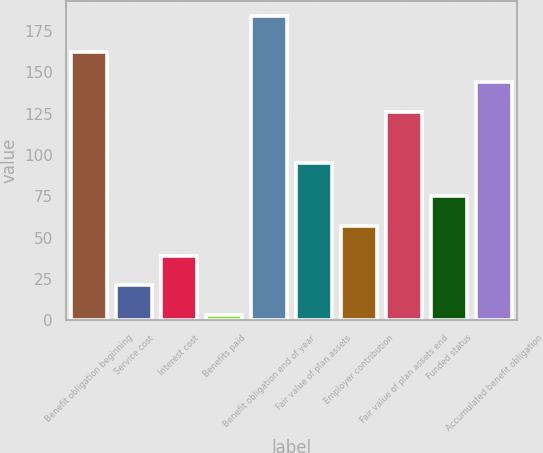Convert chart. <chart><loc_0><loc_0><loc_500><loc_500><bar_chart><fcel>Benefit obligation beginning<fcel>Service cost<fcel>Interest cost<fcel>Benefits paid<fcel>Benefit obligation end of year<fcel>Fair value of plan assets<fcel>Employer contribution<fcel>Fair value of plan assets end<fcel>Funded status<fcel>Accumulated benefit obligation<nl><fcel>162.2<fcel>21.1<fcel>39.2<fcel>3<fcel>184<fcel>95<fcel>57.3<fcel>126<fcel>75.4<fcel>144.1<nl></chart> 